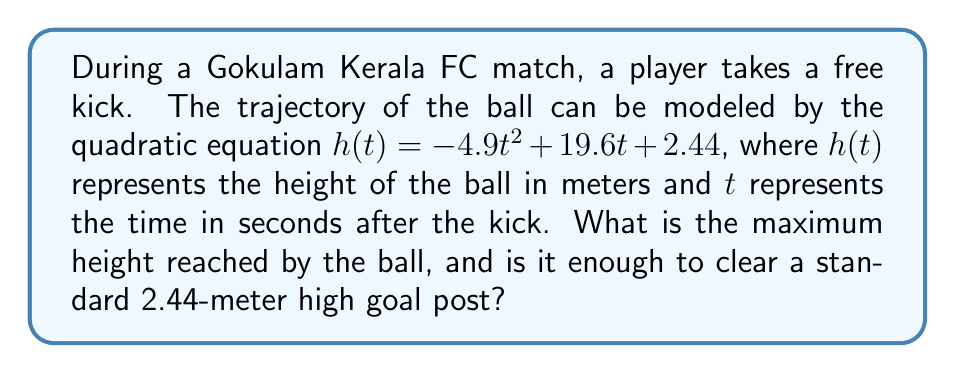Provide a solution to this math problem. To find the maximum height of the ball, we need to follow these steps:

1) The quadratic equation is in the form $h(t) = -at^2 + bt + c$, where $a = 4.9$, $b = 19.6$, and $c = 2.44$.

2) For a quadratic function, the maximum (or minimum) occurs at the vertex. The t-coordinate of the vertex is given by $t = -\frac{b}{2a}$.

3) Substituting our values:

   $t = -\frac{19.6}{2(-4.9)} = \frac{19.6}{9.8} = 2$ seconds

4) To find the maximum height, we substitute this t-value back into our original equation:

   $h(2) = -4.9(2)^2 + 19.6(2) + 2.44$
   
   $= -4.9(4) + 39.2 + 2.44$
   
   $= -19.6 + 39.2 + 2.44$
   
   $= 22.04$ meters

5) The maximum height reached by the ball is 22.04 meters.

6) Since 22.04 meters is greater than the standard goal post height of 2.44 meters, the ball will clear the goal post.
Answer: 22.04 meters; yes, it clears the goal post. 